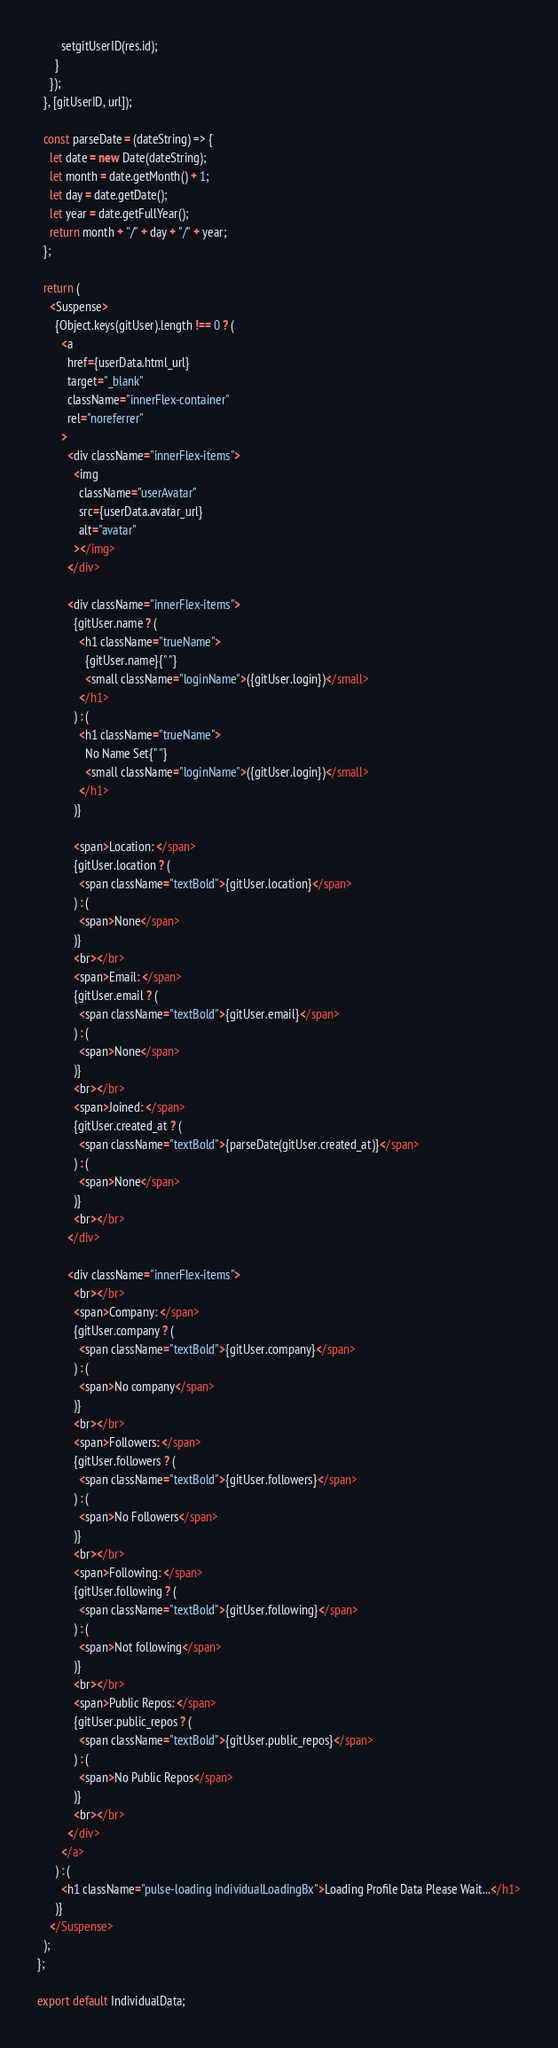<code> <loc_0><loc_0><loc_500><loc_500><_JavaScript_>        setgitUserID(res.id);
      }
    });
  }, [gitUserID, url]);

  const parseDate = (dateString) => {
    let date = new Date(dateString);
    let month = date.getMonth() + 1;
    let day = date.getDate();
    let year = date.getFullYear();
    return month + "/" + day + "/" + year;
  };

  return (
    <Suspense>
      {Object.keys(gitUser).length !== 0 ? (
        <a
          href={userData.html_url}
          target="_blank"
          className="innerFlex-container"
          rel="noreferrer"
        >
          <div className="innerFlex-items">
            <img
              className="userAvatar"
              src={userData.avatar_url}
              alt="avatar"
            ></img>
          </div>

          <div className="innerFlex-items">
            {gitUser.name ? (
              <h1 className="trueName">
                {gitUser.name}{" "}
                <small className="loginName">({gitUser.login})</small>
              </h1>
            ) : (
              <h1 className="trueName">
                No Name Set{" "}
                <small className="loginName">({gitUser.login})</small>
              </h1>
            )}

            <span>Location: </span>
            {gitUser.location ? (
              <span className="textBold">{gitUser.location}</span>
            ) : (
              <span>None</span>
            )}
            <br></br>
            <span>Email: </span>
            {gitUser.email ? (
              <span className="textBold">{gitUser.email}</span>
            ) : (
              <span>None</span>
            )}
            <br></br>
            <span>Joined: </span>
            {gitUser.created_at ? (
              <span className="textBold">{parseDate(gitUser.created_at)}</span>
            ) : (
              <span>None</span>
            )}
            <br></br>
          </div>

          <div className="innerFlex-items">
            <br></br>
            <span>Company: </span>
            {gitUser.company ? (
              <span className="textBold">{gitUser.company}</span>
            ) : (
              <span>No company</span>
            )}
            <br></br>
            <span>Followers: </span>
            {gitUser.followers ? (
              <span className="textBold">{gitUser.followers}</span>
            ) : (
              <span>No Followers</span>
            )}
            <br></br>
            <span>Following: </span>
            {gitUser.following ? (
              <span className="textBold">{gitUser.following}</span>
            ) : (
              <span>Not following</span>
            )}
            <br></br>
            <span>Public Repos: </span>
            {gitUser.public_repos ? (
              <span className="textBold">{gitUser.public_repos}</span>
            ) : (
              <span>No Public Repos</span>
            )}
            <br></br>
          </div>
        </a>
      ) : (
        <h1 className="pulse-loading individualLoadingBx">Loading Profile Data Please Wait...</h1>
      )}
    </Suspense>
  );
};

export default IndividualData;
</code> 